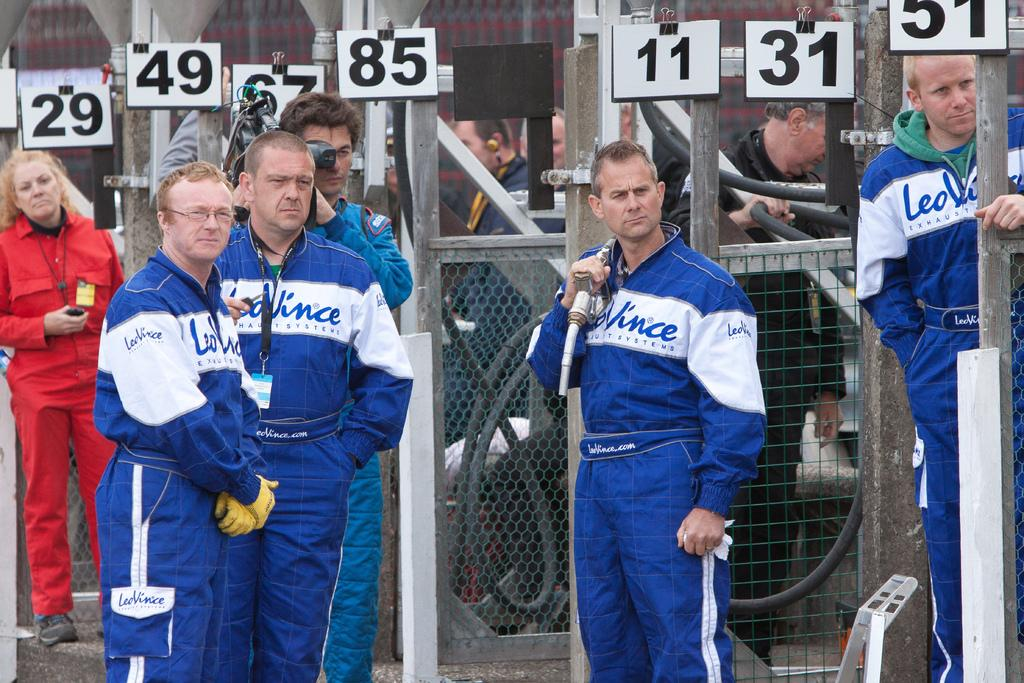<image>
Create a compact narrative representing the image presented. Men wearing a jersey which says "Vince" on it under some numbers. 